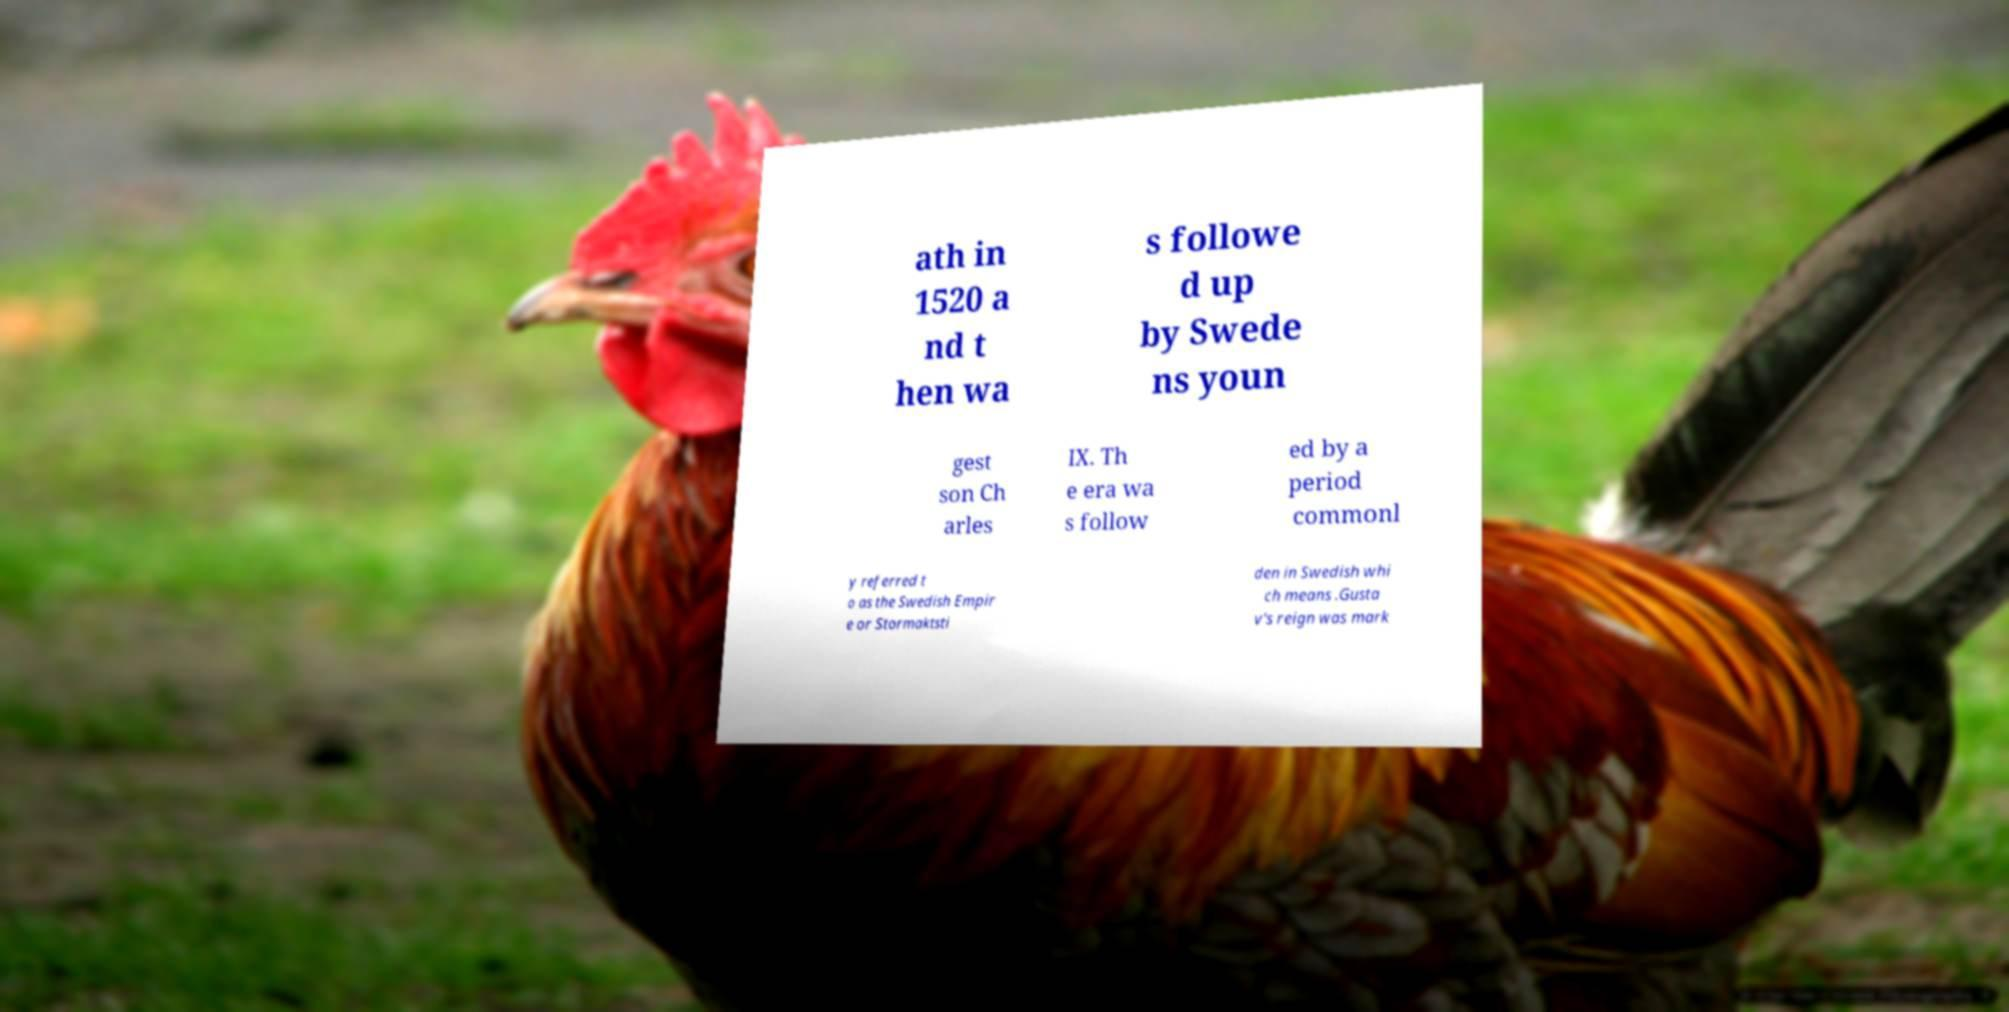Can you read and provide the text displayed in the image?This photo seems to have some interesting text. Can you extract and type it out for me? ath in 1520 a nd t hen wa s followe d up by Swede ns youn gest son Ch arles IX. Th e era wa s follow ed by a period commonl y referred t o as the Swedish Empir e or Stormaktsti den in Swedish whi ch means .Gusta v's reign was mark 